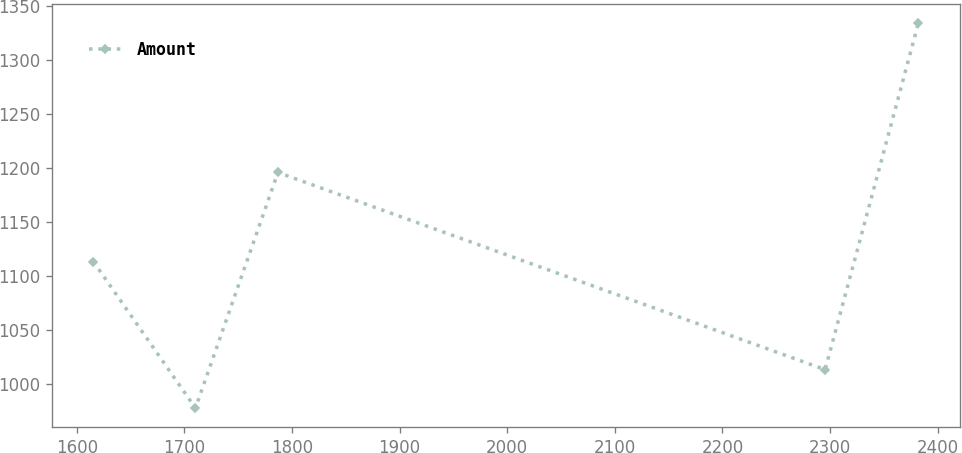Convert chart to OTSL. <chart><loc_0><loc_0><loc_500><loc_500><line_chart><ecel><fcel>Amount<nl><fcel>1615.5<fcel>1112.98<nl><fcel>1710.35<fcel>977.35<nl><fcel>1787.01<fcel>1195.58<nl><fcel>2295.48<fcel>1012.98<nl><fcel>2382.06<fcel>1333.62<nl></chart> 